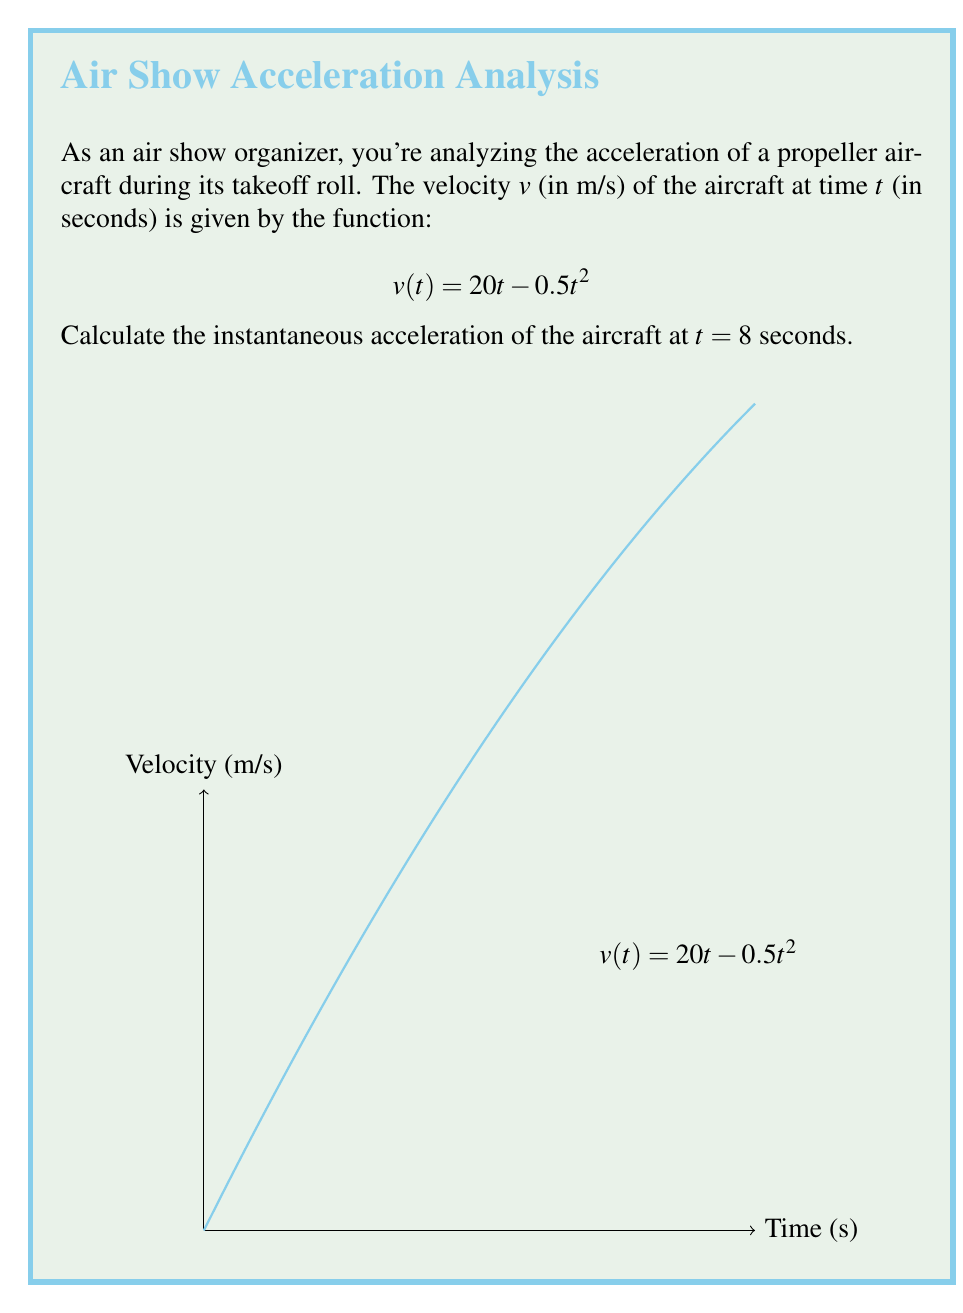Help me with this question. To find the instantaneous acceleration at $t = 8$ seconds, we need to follow these steps:

1) Recall that acceleration is the derivative of velocity with respect to time. So, we need to find $\frac{dv}{dt}$.

2) Given velocity function: $v(t) = 20t - 0.5t^2$

3) To find $\frac{dv}{dt}$, we use the power rule of differentiation:
   $$\frac{dv}{dt} = 20 - t$$

4) This function $\frac{dv}{dt}$ represents the acceleration at any time $t$.

5) To find the acceleration at $t = 8$ seconds, we substitute $t = 8$ into our acceleration function:
   $$a(8) = 20 - 8 = 12$$

Therefore, the instantaneous acceleration of the aircraft at $t = 8$ seconds is 12 m/s².
Answer: $12$ m/s² 